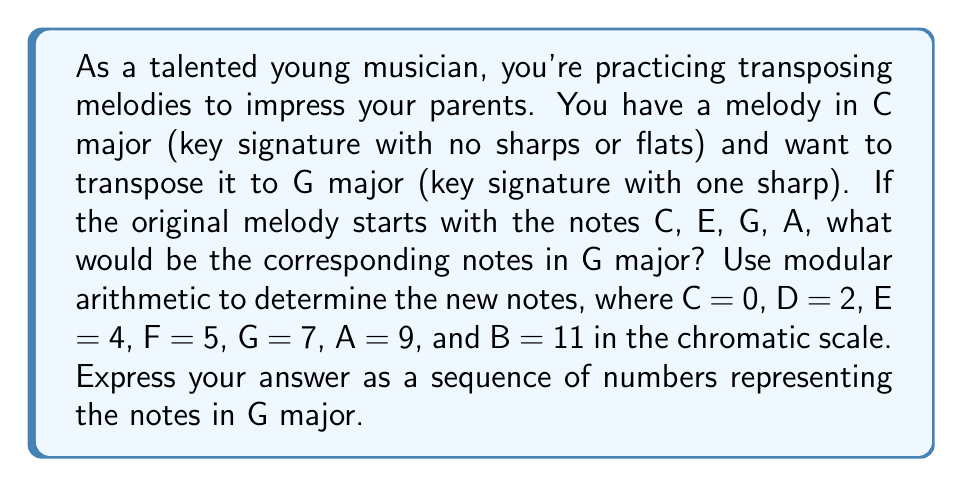Teach me how to tackle this problem. To transpose the melody from C major to G major, we need to shift each note up by 7 semitones (the interval between C and G). We can use modular arithmetic with modulus 12 (since there are 12 semitones in an octave) to perform this transposition.

Given:
C = 0, E = 4, G = 7, A = 9

Step 1: Add 7 to each note value and apply modulo 12.

For C: $(0 + 7) \bmod 12 = 7 \bmod 12 = 7$ (G)
For E: $(4 + 7) \bmod 12 = 11 \bmod 12 = 11$ (B)
For G: $(7 + 7) \bmod 12 = 14 \bmod 12 = 2$ (D)
For A: $(9 + 7) \bmod 12 = 16 \bmod 12 = 4$ (E)

Step 2: Convert the resulting numbers back to note names:
7 = G, 11 = B, 2 = D, 4 = E

Therefore, the transposed melody in G major is: G, B, D, E
Answer: 7, 11, 2, 4 